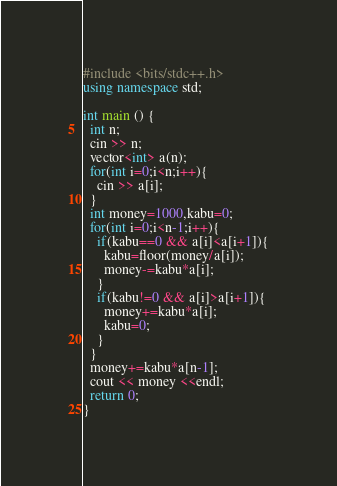Convert code to text. <code><loc_0><loc_0><loc_500><loc_500><_C++_>#include <bits/stdc++.h>
using namespace std;

int main () {
  int n;
  cin >> n;
  vector<int> a(n);
  for(int i=0;i<n;i++){
    cin >> a[i];
  }
  int money=1000,kabu=0;
  for(int i=0;i<n-1;i++){
    if(kabu==0 && a[i]<a[i+1]){
      kabu=floor(money/a[i]);
      money-=kabu*a[i];
    }
    if(kabu!=0 && a[i]>a[i+1]){
      money+=kabu*a[i];
      kabu=0;
    }
  }
  money+=kabu*a[n-1];
  cout << money <<endl;
  return 0;
}</code> 